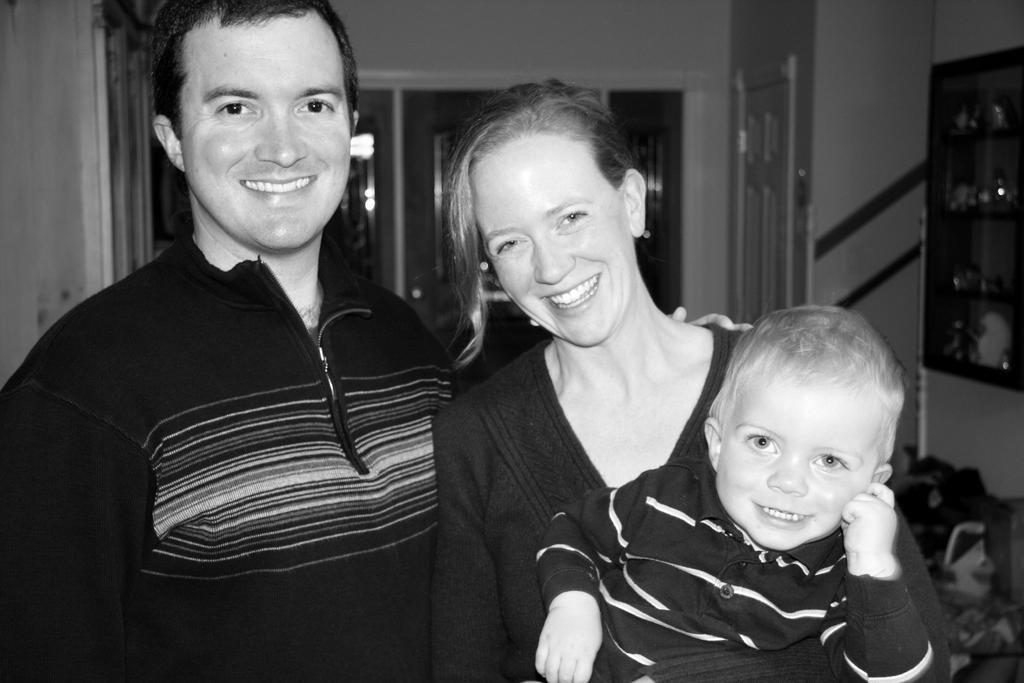Please provide a concise description of this image. This picture is in black and white. In the picture, there is a man, woman and a kid. Woman is holding the kid. Towards the right, there is a shelf filled with objects. In the background, there are doors. 